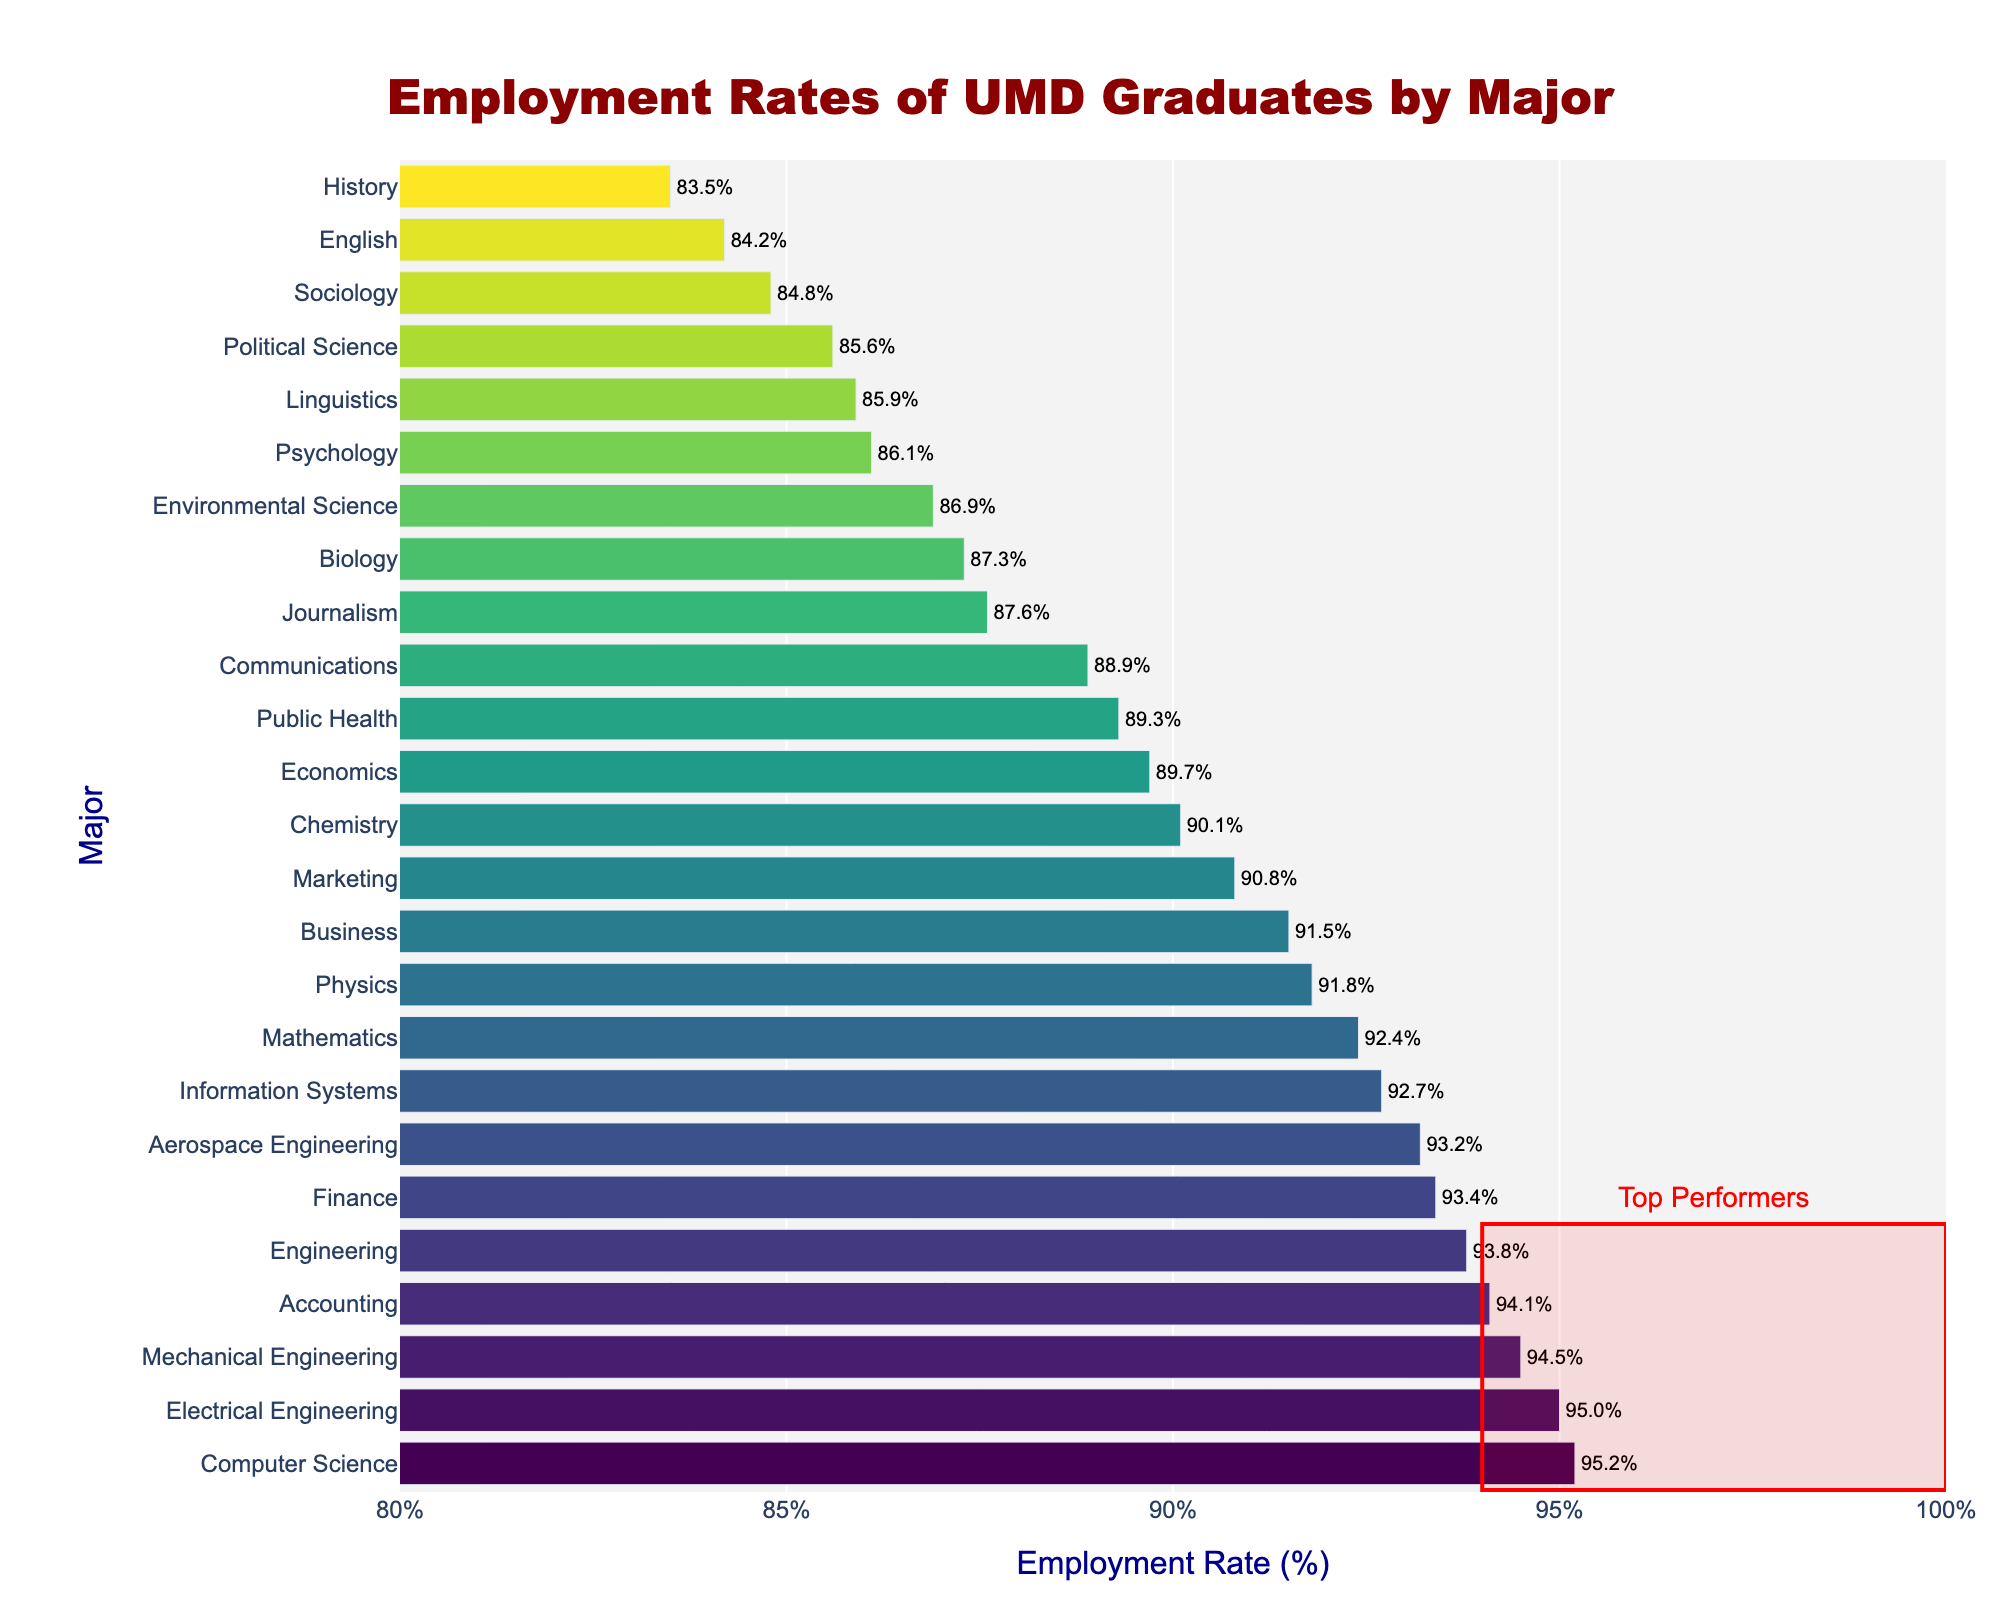Which major has the highest employment rate? From the bar chart, the major with the highest bar represents the major with the highest employment rate. Computer Science has the highest employment rate of 95.2%.
Answer: Computer Science What is the employment rate difference between Computer Science and Psychology? The employment rate for Computer Science is 95.2%, and for Psychology, it is 86.1%. The difference is 95.2% - 86.1% = 9.1%.
Answer: 9.1% Which majors are identified as top performers in the plot, and what's their employment rate range? The top performers are highlighted with a rectangle and annotation in the plot. They have employment rates between 94% and 100%. The top performers are Computer Science (95.2%), Electrical Engineering (95.0%), Mechanical Engineering (94.5%), and Accounting (94.1%).
Answer: 94%-100% What is the average employment rate for the top five majors? The employment rates for the top five majors are: Computer Science (95.2%), Electrical Engineering (95.0%), Mechanical Engineering (94.5%), Accounting (94.1%), and Engineering (93.8%). The average is (95.2 + 95.0 + 94.5 + 94.1 + 93.8) / 5 = 94.52%.
Answer: 94.52% Which major has a higher employment rate, Finance or Marketing? By comparing the heights of the bars, Finance has an employment rate of 93.4%, while Marketing has 90.8%. Thus, Finance has a higher employment rate than Marketing.
Answer: Finance How many majors have employment rates higher than 90%? Count the bars representing majors with employment rates above 90%. They are: Computer Science, Electrical Engineering, Mechanical Engineering, Accounting, Engineering, Mathematics, Physics, Finance, Information Systems, and Chemistry. There are 10 majors with employment rates higher than 90%.
Answer: 10 What is the employment rate range for all the majors in the plot? Identify the shortest and tallest bars in the plot. The lowest employment rate is for History at 83.5%, and the highest is for Computer Science at 95.2%. Therefore, the range is 83.5% to 95.2%.
Answer: 83.5%-95.2% Compare the employment rates between Environmental Science and Public Health. Which one is higher and by how much? Environmental Science has an employment rate of 86.9%, while Public Health has 89.3%. Public Health is higher by 89.3% - 86.9% = 2.4%.
Answer: Public Health by 2.4% What is the employment rate for the major at the median position in the sorted list? First, identify the median position in the sorted list of majors. With 25 majors, the median is at the 13th position. The 13th major in the list is Environmental Science with an employment rate of 86.9%.
Answer: 86.9% How does the employment rate of Linguistics compare to the average employment rate of all the majors? To find the average employment rate, sum the employment rates of all majors and divide by the number of majors. The sum is 2195.8. The average is 2195.8 / 25 = 87.832%. Linguistics has an employment rate of 85.9%, which is lower than the average.
Answer: Linguistics is lower 